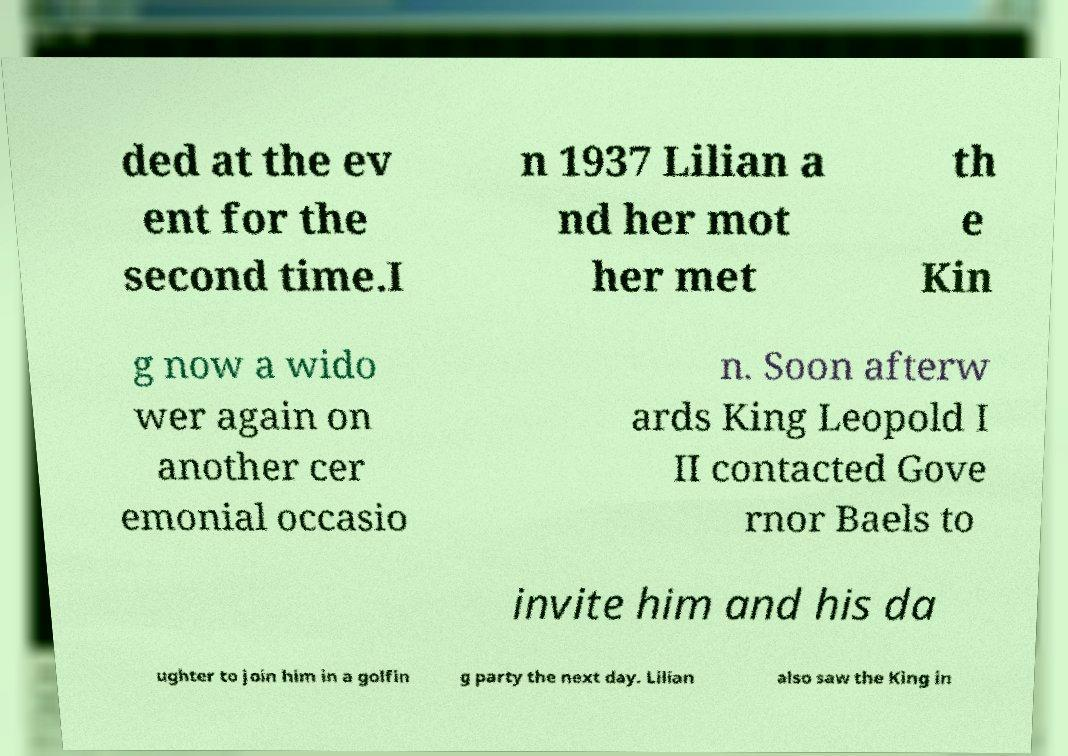Could you assist in decoding the text presented in this image and type it out clearly? ded at the ev ent for the second time.I n 1937 Lilian a nd her mot her met th e Kin g now a wido wer again on another cer emonial occasio n. Soon afterw ards King Leopold I II contacted Gove rnor Baels to invite him and his da ughter to join him in a golfin g party the next day. Lilian also saw the King in 